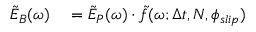Convert formula to latex. <formula><loc_0><loc_0><loc_500><loc_500>\begin{array} { r l } { \tilde { E } _ { B } ( \omega ) } & = \tilde { E } _ { P } ( \omega ) \cdot \tilde { f } ( \omega ; \Delta t , N , \phi _ { s l i p } ) } \end{array}</formula> 